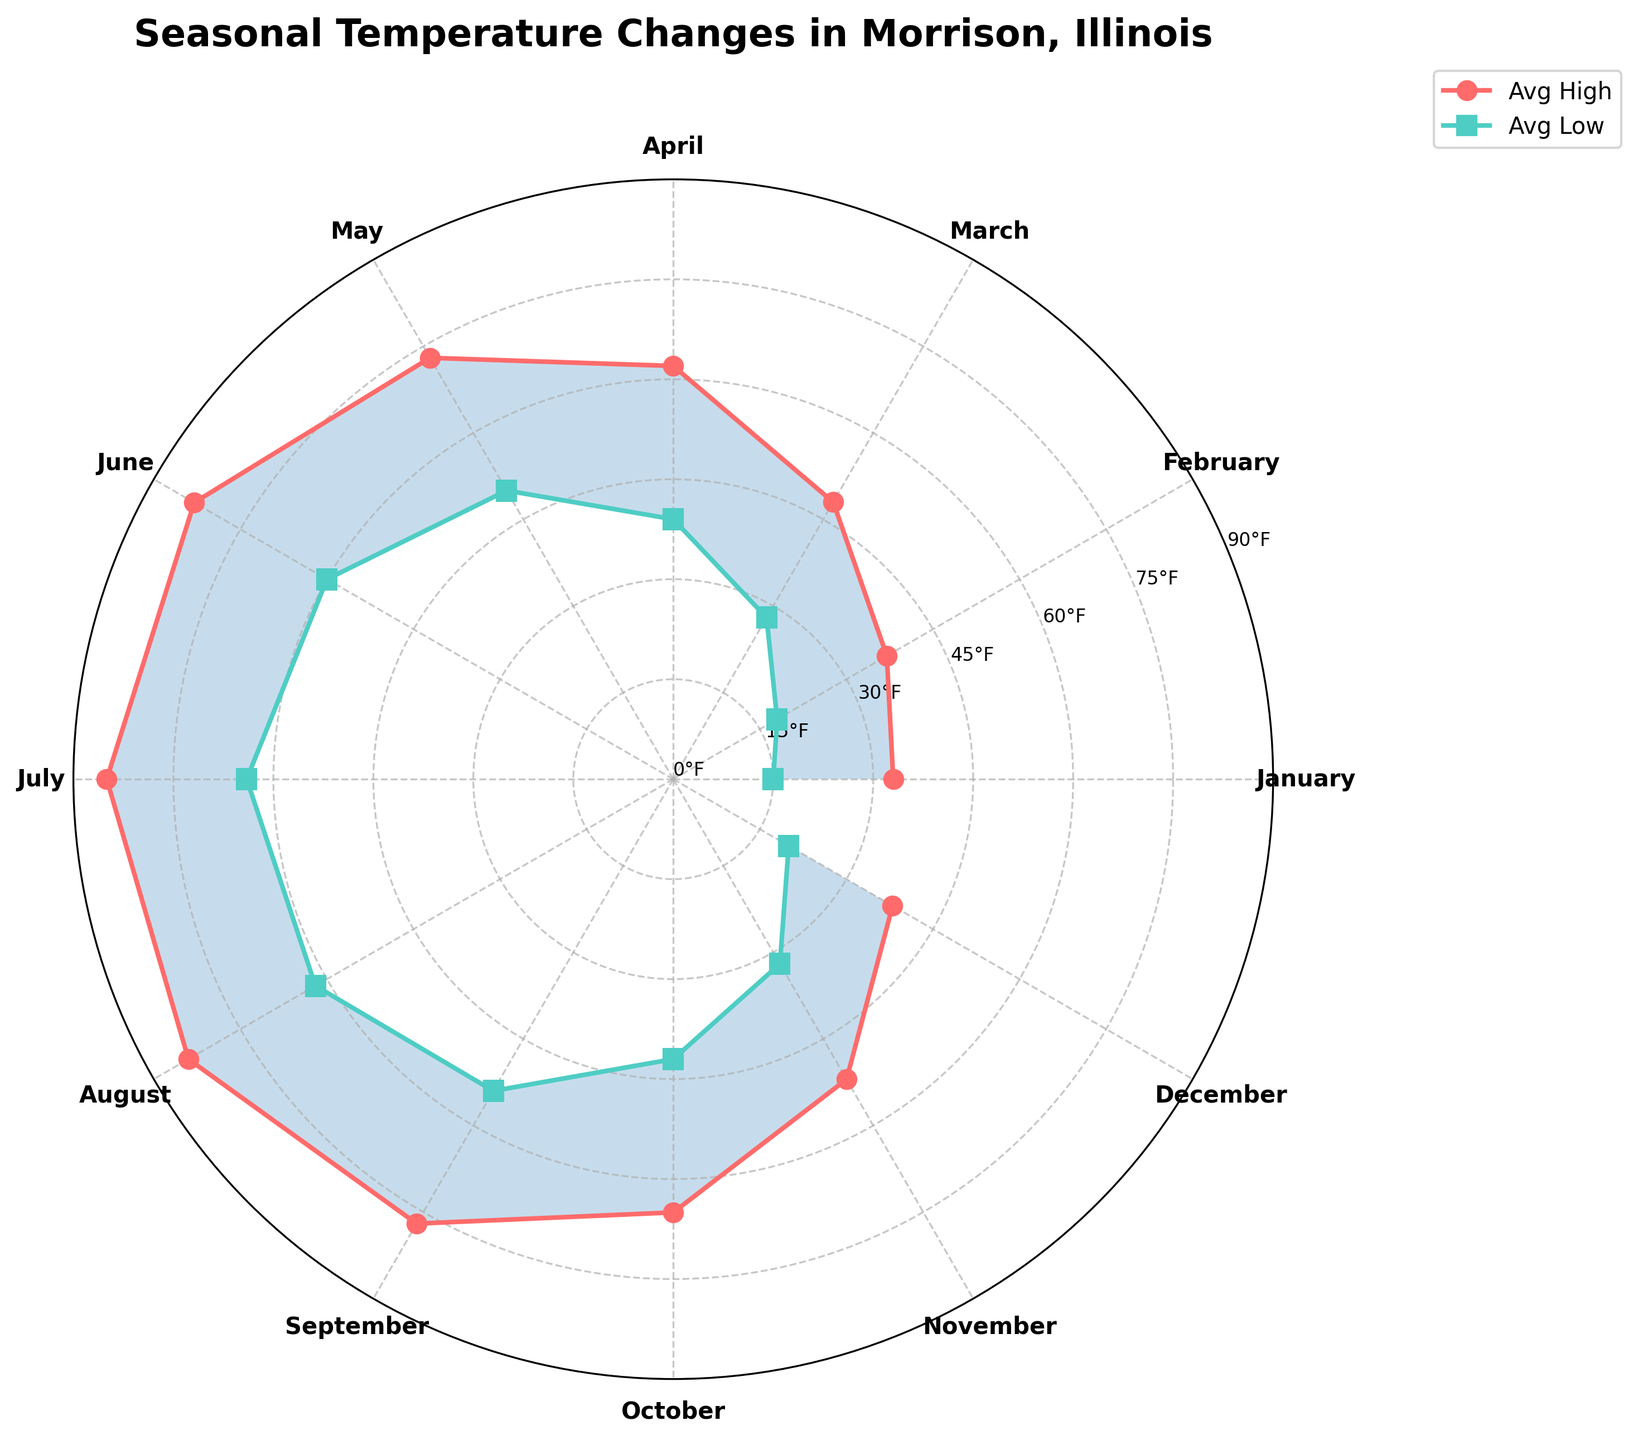What is the title of the polar chart? The title is located at the top of the chart. It reads: "Seasonal Temperature Changes in Morrison, Illinois"
Answer: Seasonal Temperature Changes in Morrison, Illinois Which month shows the highest average high temperature? The highest average high temperature is identified by the peak of the red line. July has the highest peak.
Answer: July What are the average high and low temperatures in March? Looking at the positions of the data points on the chart corresponding to March, the average high is 48°F and the average low is 28°F.
Answer: 48°F (High), 28°F (Low) How many months have an average high temperature of 80°F or above? Checking the chart, June, July, and August have average high temperatures of 80°F or above.
Answer: 3 months Which month has the lowest average low temperature? The lowest average low temperature is represented by the lowest point on the blue line. January shows the lowest point.
Answer: January What is the difference in the average high and low temperatures in December? For December, observe the corresponding data points: the high is 38°F and the low is 20°F. The difference is 38 - 20.
Answer: 18°F Compare the average high temperature in May and September. Which month is warmer? May's average high is 73°F, and September’s average high is 77°F. Comparing these values, September is warmer.
Answer: September What is the average range of temperatures (difference between high and low) in June? In June, the average high is 83°F and the average low is 60°F. The range is 83 - 60.
Answer: 23°F During which month do the average high and low temperatures differ the most? To find this, calculate the temperature range for each month and identify the maximum range. January shows the highest difference: 33 - 15 = 18°F.
Answer: January How does the average high temperature change from April to September? Starting from April to September, observe the red line’s elevation: it rises from 62°F in April, peaks, and then slightly drops to 77°F in September. The overall trend increases towards summer months and then starts decreasing.
Answer: Increases, then decreases 